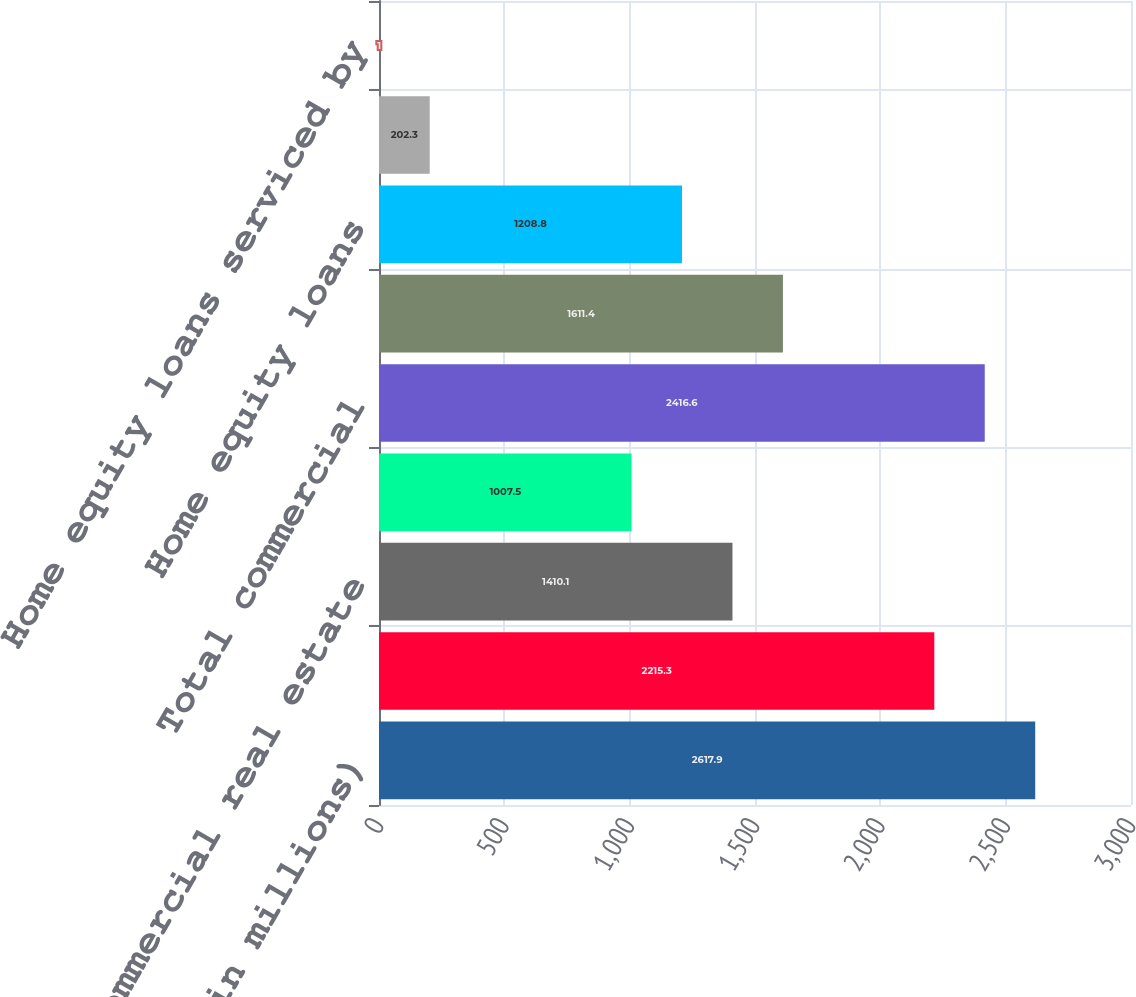Convert chart to OTSL. <chart><loc_0><loc_0><loc_500><loc_500><bar_chart><fcel>(dollars in millions)<fcel>Commercial<fcel>Commercial real estate<fcel>Leases<fcel>Total commercial<fcel>Residential mortgages<fcel>Home equity loans<fcel>Home equity lines of credit<fcel>Home equity loans serviced by<nl><fcel>2617.9<fcel>2215.3<fcel>1410.1<fcel>1007.5<fcel>2416.6<fcel>1611.4<fcel>1208.8<fcel>202.3<fcel>1<nl></chart> 